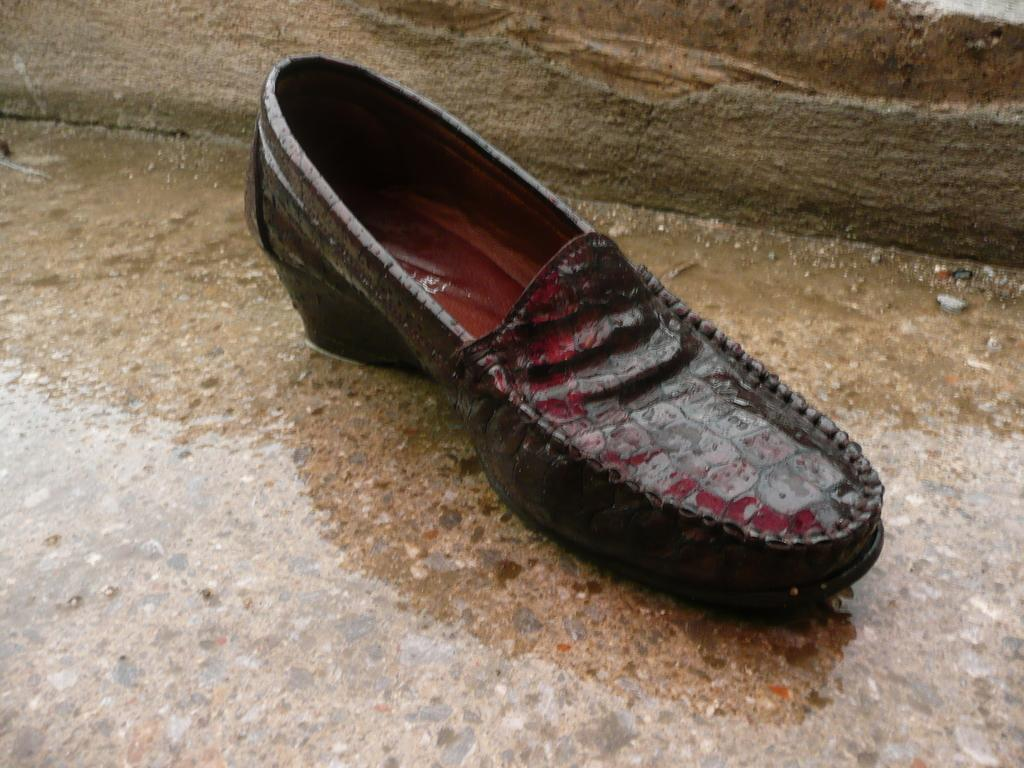What is the condition of the shoe in the image? The shoe in the image is wet. What is the surface beneath the shoe? The shoe is placed on a wet ground. What type of fork can be seen in the image? There is no fork present in the image. What emotion is the shoe expressing in the image? The shoe is an inanimate object and cannot express emotions like love. 